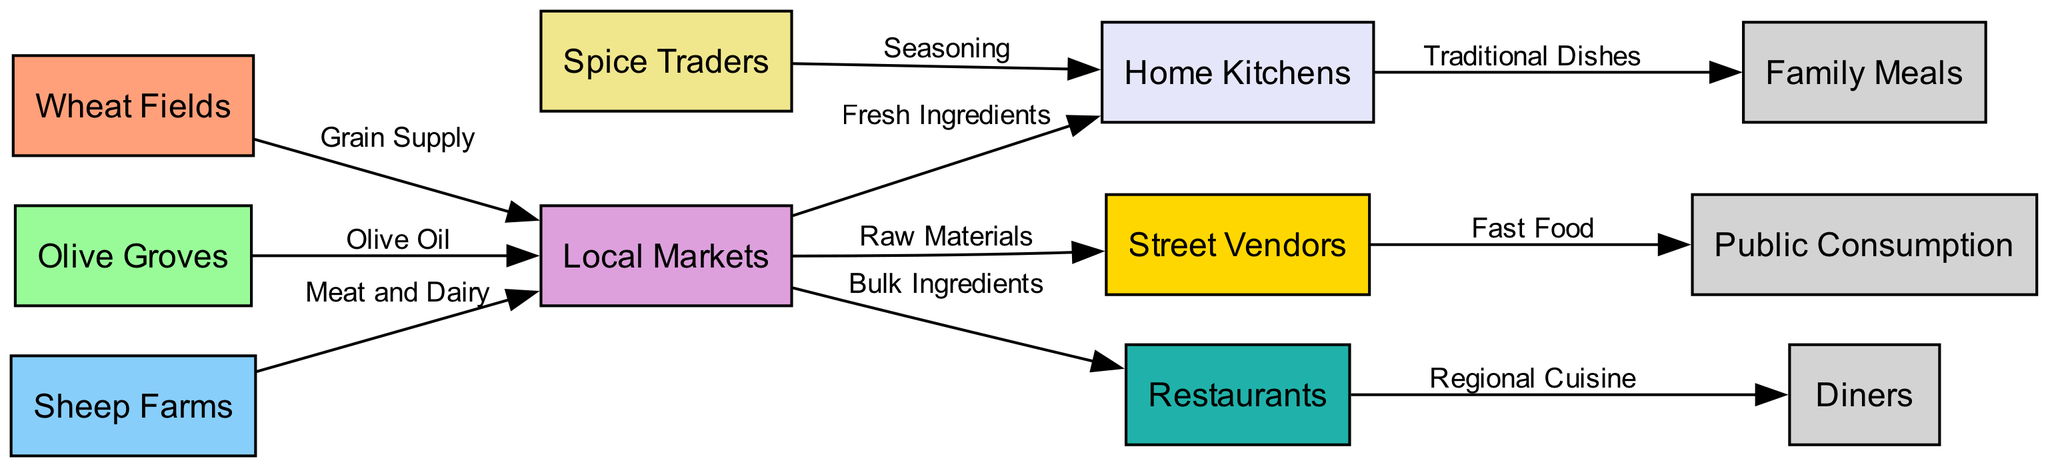What are the primary agricultural sources in this food chain? The diagram shows three main agricultural sources: Wheat Fields, Olive Groves, and Sheep Farms, as indicated by the nodes representing these elements.
Answer: Wheat Fields, Olive Groves, Sheep Farms How many nodes are present in the diagram? By counting the unique nodes in the diagram, we identify a total of 8 different nodes.
Answer: 8 What is supplied from Olive Groves to Local Markets? The edge connecting Olive Groves to Local Markets is labeled "Olive Oil," indicating that this product is supplied from the groves to the market.
Answer: Olive Oil What is the role of Local Markets in this food chain? Local Markets serve as a hub where ingredients from Wheat Fields, Olive Groves, and Sheep Farms are collected, which are then distributed to Home Kitchens, Street Vendors, and Restaurants.
Answer: Supply hub Which two entities are directly connected by the edge labeled "Fast Food"? The edge labeled "Fast Food" connects Street Vendors to Public Consumption, indicating that street vendors provide food for public enjoyment.
Answer: Street Vendors, Public Consumption From Home Kitchens, what type of meals are produced? The edge leading from Home Kitchens to Family Meals is labeled "Traditional Dishes," indicating that meals prepared in kitchens consist of traditional recipes.
Answer: Traditional Dishes What is the relationship between Local Markets and Restaurants? Local Markets supply bulk ingredients to Restaurants, as shown by the direct edge labeled "Bulk Ingredients" connecting these two nodes.
Answer: Supply of Bulk Ingredients Which node receives seasoning from Spice Traders? The edge from Spice Traders leads to Home Kitchens and is labeled "Seasoning," indicating that Home Kitchens receive seasoning to enhance their dishes.
Answer: Home Kitchens 